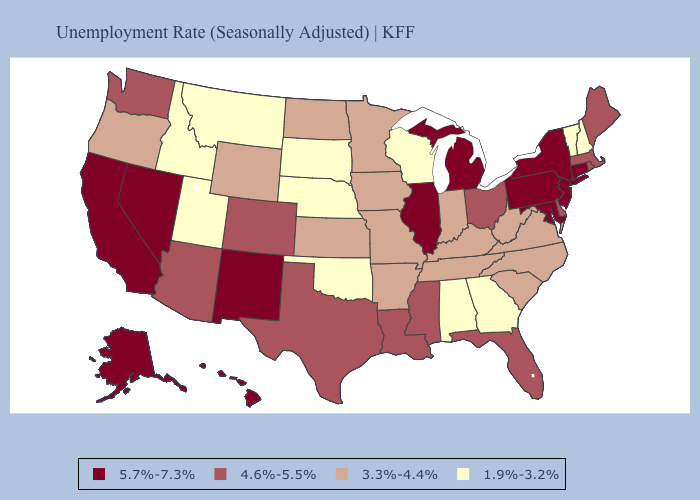Does Maine have the lowest value in the Northeast?
Keep it brief. No. Does Alaska have the lowest value in the West?
Short answer required. No. Name the states that have a value in the range 3.3%-4.4%?
Short answer required. Arkansas, Indiana, Iowa, Kansas, Kentucky, Minnesota, Missouri, North Carolina, North Dakota, Oregon, South Carolina, Tennessee, Virginia, West Virginia, Wyoming. Does Utah have the lowest value in the West?
Concise answer only. Yes. Does Alabama have the lowest value in the South?
Concise answer only. Yes. Name the states that have a value in the range 4.6%-5.5%?
Give a very brief answer. Arizona, Colorado, Delaware, Florida, Louisiana, Maine, Massachusetts, Mississippi, Ohio, Rhode Island, Texas, Washington. Which states hav the highest value in the West?
Concise answer only. Alaska, California, Hawaii, Nevada, New Mexico. Name the states that have a value in the range 5.7%-7.3%?
Answer briefly. Alaska, California, Connecticut, Hawaii, Illinois, Maryland, Michigan, Nevada, New Jersey, New Mexico, New York, Pennsylvania. What is the highest value in states that border Colorado?
Be succinct. 5.7%-7.3%. Which states have the lowest value in the South?
Keep it brief. Alabama, Georgia, Oklahoma. Name the states that have a value in the range 3.3%-4.4%?
Keep it brief. Arkansas, Indiana, Iowa, Kansas, Kentucky, Minnesota, Missouri, North Carolina, North Dakota, Oregon, South Carolina, Tennessee, Virginia, West Virginia, Wyoming. What is the value of Louisiana?
Be succinct. 4.6%-5.5%. How many symbols are there in the legend?
Quick response, please. 4. Does Utah have the same value as California?
Keep it brief. No. What is the value of Maine?
Be succinct. 4.6%-5.5%. 